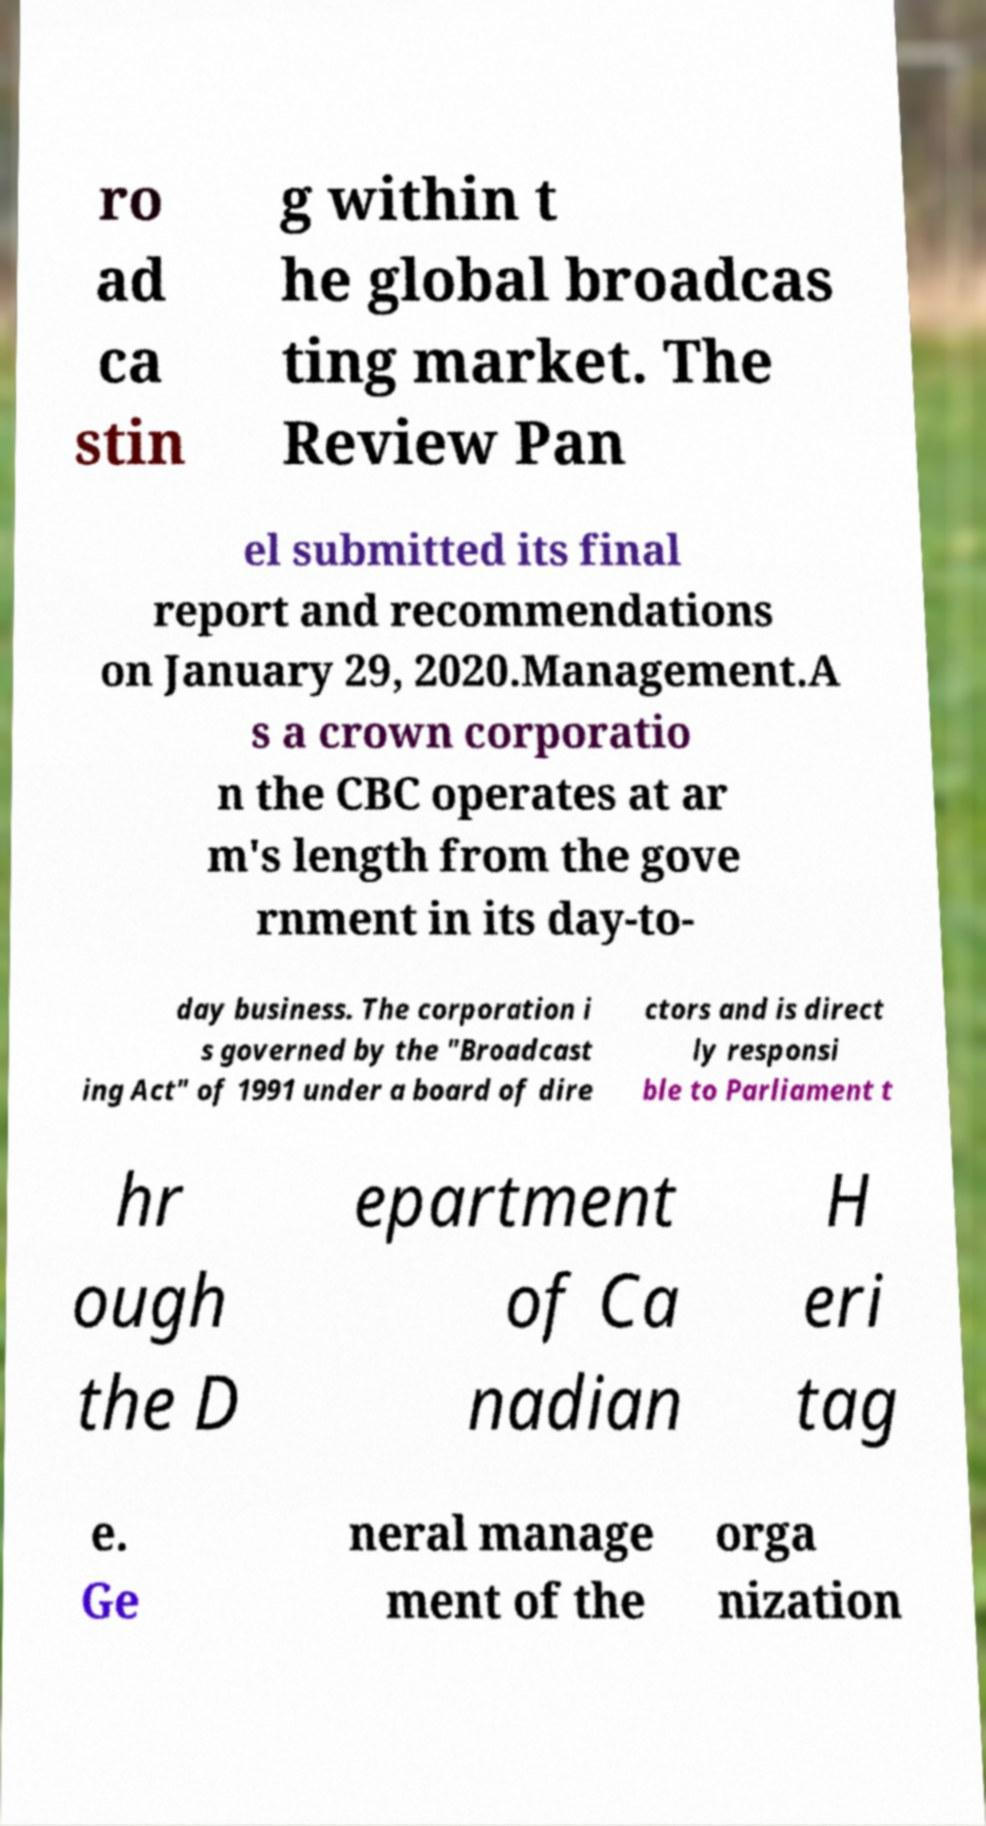Please read and relay the text visible in this image. What does it say? ro ad ca stin g within t he global broadcas ting market. The Review Pan el submitted its final report and recommendations on January 29, 2020.Management.A s a crown corporatio n the CBC operates at ar m's length from the gove rnment in its day-to- day business. The corporation i s governed by the "Broadcast ing Act" of 1991 under a board of dire ctors and is direct ly responsi ble to Parliament t hr ough the D epartment of Ca nadian H eri tag e. Ge neral manage ment of the orga nization 